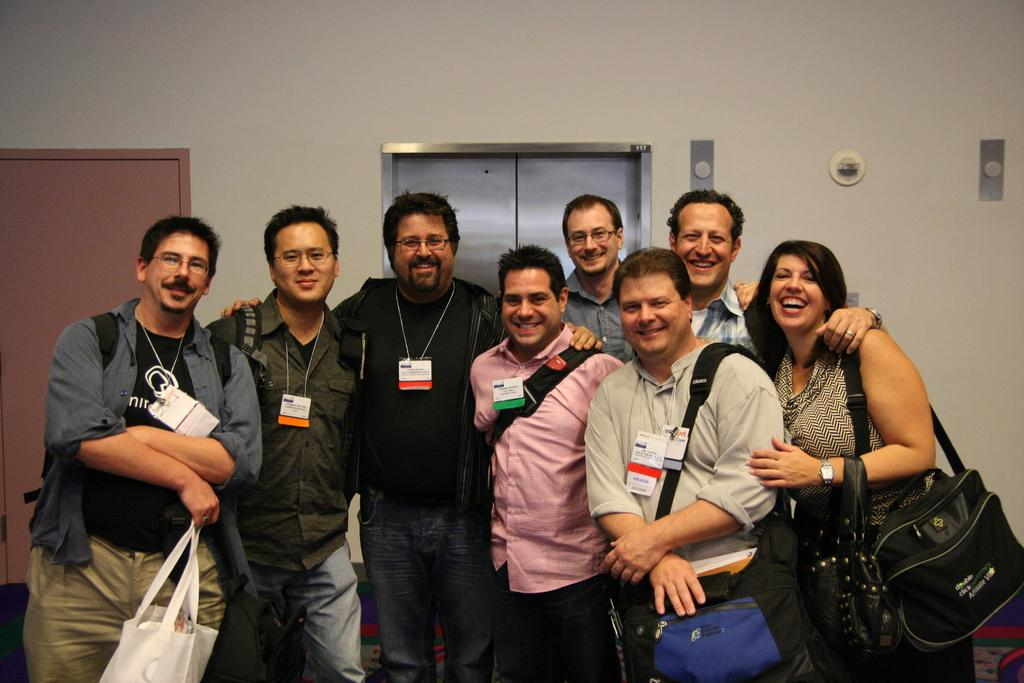Who is present in the image? There are people in the image. What are the people wearing that can be seen in the image? The people are wearing ID cards. What are the people carrying in the image? The people are carrying bags. What can be seen in the background of the image? There is a wall in the background of the image. What type of base is visible in the image? There is no base present in the image. What property is being managed by the people in the image? The image does not provide information about any property being managed by the people. 